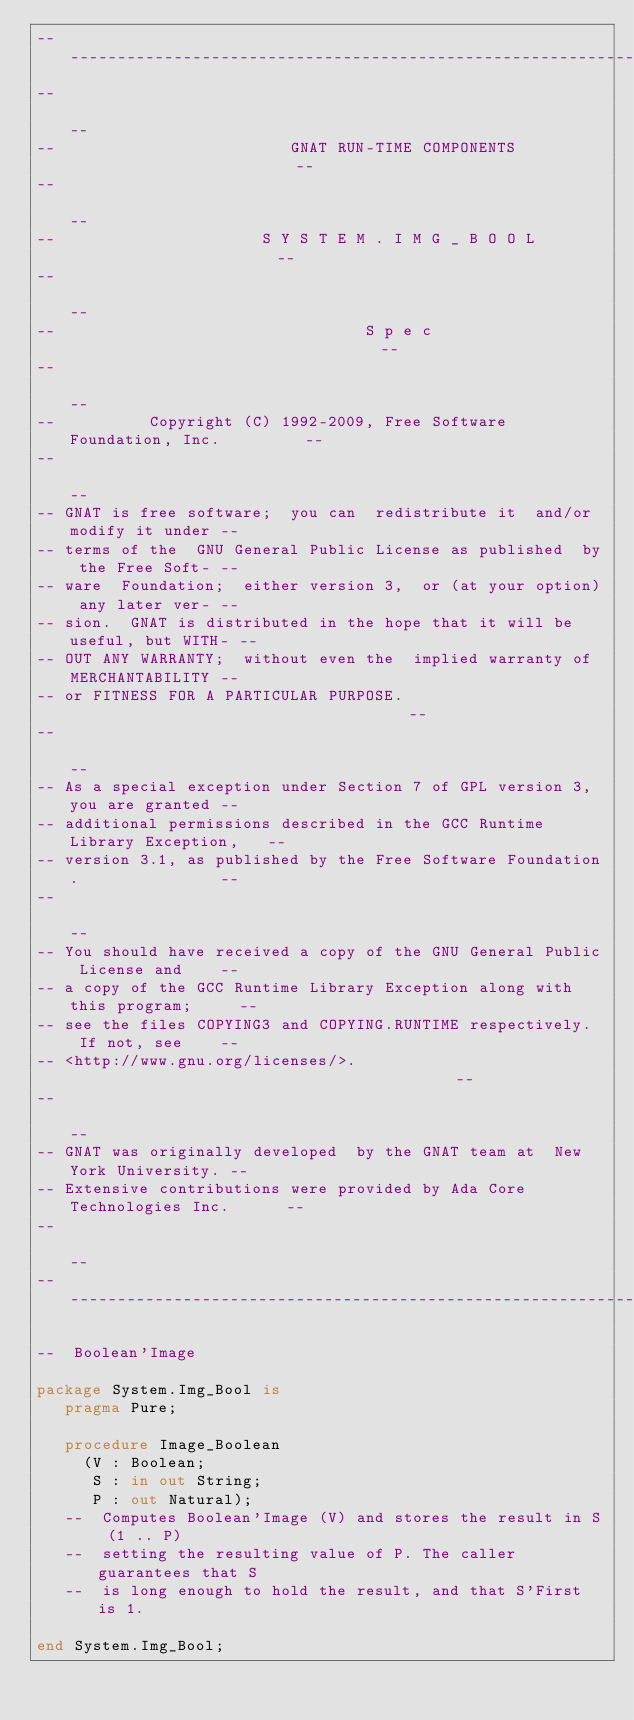<code> <loc_0><loc_0><loc_500><loc_500><_Ada_>------------------------------------------------------------------------------
--                                                                          --
--                         GNAT RUN-TIME COMPONENTS                         --
--                                                                          --
--                      S Y S T E M . I M G _ B O O L                       --
--                                                                          --
--                                 S p e c                                  --
--                                                                          --
--          Copyright (C) 1992-2009, Free Software Foundation, Inc.         --
--                                                                          --
-- GNAT is free software;  you can  redistribute it  and/or modify it under --
-- terms of the  GNU General Public License as published  by the Free Soft- --
-- ware  Foundation;  either version 3,  or (at your option) any later ver- --
-- sion.  GNAT is distributed in the hope that it will be useful, but WITH- --
-- OUT ANY WARRANTY;  without even the  implied warranty of MERCHANTABILITY --
-- or FITNESS FOR A PARTICULAR PURPOSE.                                     --
--                                                                          --
-- As a special exception under Section 7 of GPL version 3, you are granted --
-- additional permissions described in the GCC Runtime Library Exception,   --
-- version 3.1, as published by the Free Software Foundation.               --
--                                                                          --
-- You should have received a copy of the GNU General Public License and    --
-- a copy of the GCC Runtime Library Exception along with this program;     --
-- see the files COPYING3 and COPYING.RUNTIME respectively.  If not, see    --
-- <http://www.gnu.org/licenses/>.                                          --
--                                                                          --
-- GNAT was originally developed  by the GNAT team at  New York University. --
-- Extensive contributions were provided by Ada Core Technologies Inc.      --
--                                                                          --
------------------------------------------------------------------------------

--  Boolean'Image

package System.Img_Bool is
   pragma Pure;

   procedure Image_Boolean
     (V : Boolean;
      S : in out String;
      P : out Natural);
   --  Computes Boolean'Image (V) and stores the result in S (1 .. P)
   --  setting the resulting value of P. The caller guarantees that S
   --  is long enough to hold the result, and that S'First is 1.

end System.Img_Bool;
</code> 